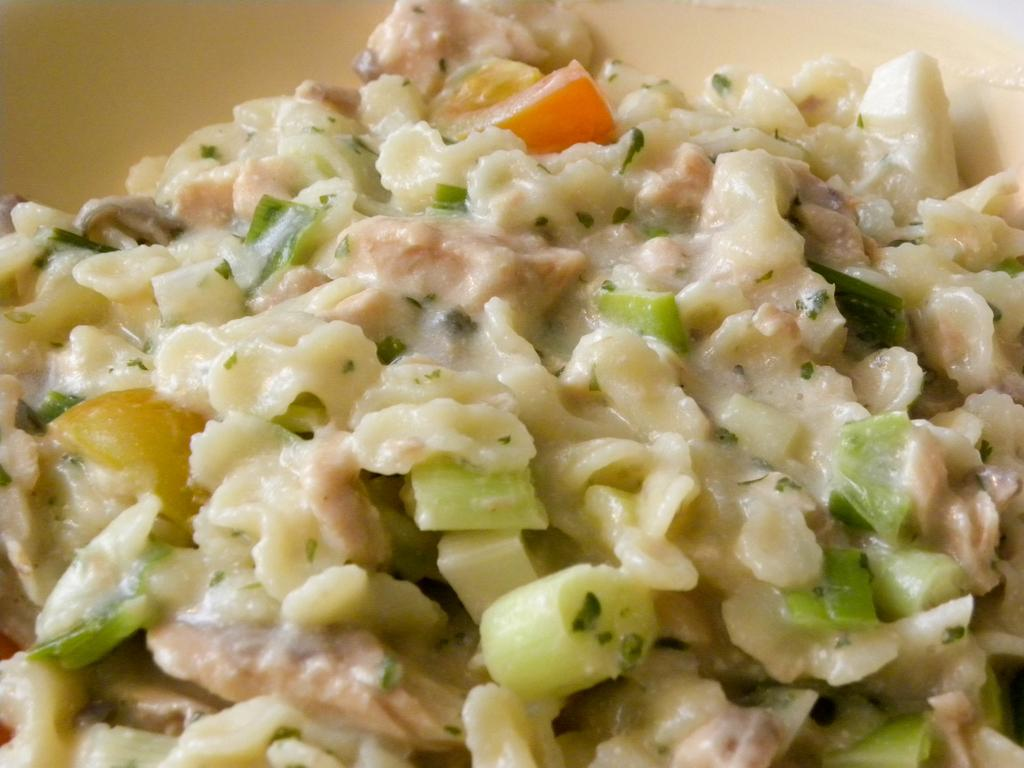What can be seen in the image? There is food in the image. How many stitches are visible on the food in the image? There are no stitches visible on the food in the image, as stitches are not a characteristic of food. 